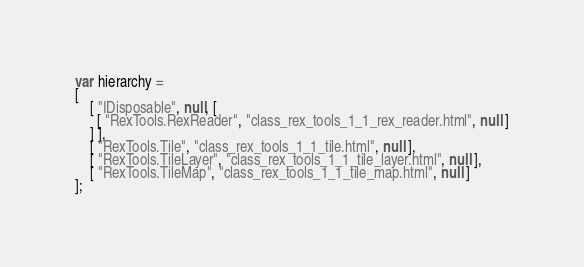<code> <loc_0><loc_0><loc_500><loc_500><_JavaScript_>var hierarchy =
[
    [ "IDisposable", null, [
      [ "RexTools.RexReader", "class_rex_tools_1_1_rex_reader.html", null ]
    ] ],
    [ "RexTools.Tile", "class_rex_tools_1_1_tile.html", null ],
    [ "RexTools.TileLayer", "class_rex_tools_1_1_tile_layer.html", null ],
    [ "RexTools.TileMap", "class_rex_tools_1_1_tile_map.html", null ]
];</code> 